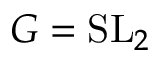<formula> <loc_0><loc_0><loc_500><loc_500>G = { S L } _ { 2 }</formula> 